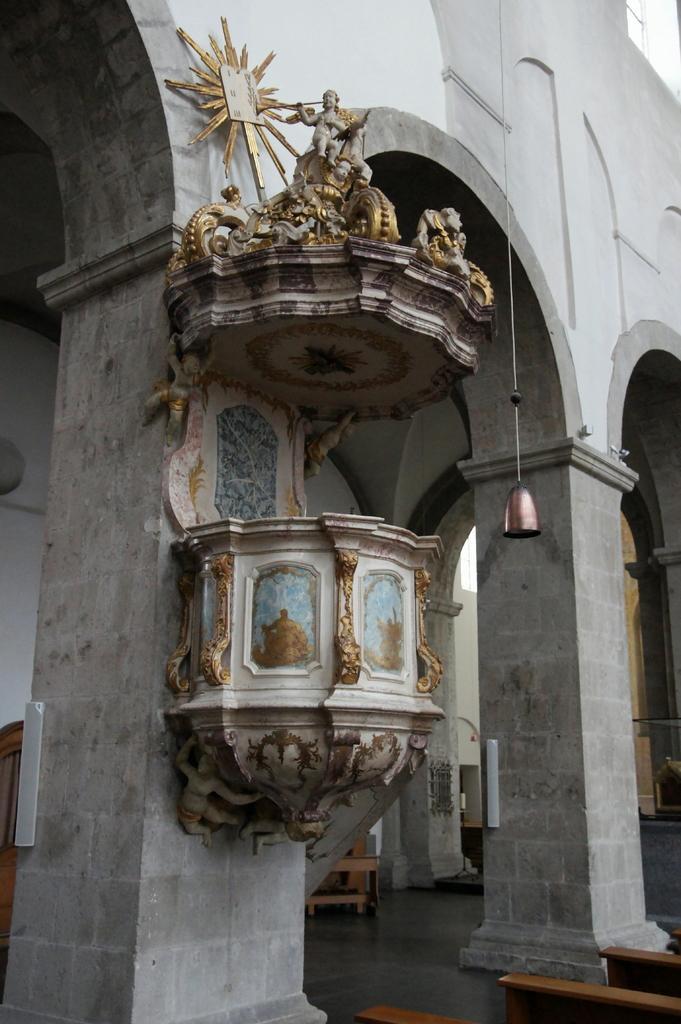Could you give a brief overview of what you see in this image? In this image I can see the building. To the building I can see the statues which are in gold and ash color. I can also see the benches on the floor. 